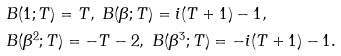Convert formula to latex. <formula><loc_0><loc_0><loc_500><loc_500>& B ( 1 ; T ) = T , \ B ( \beta ; T ) = i ( T + 1 ) - 1 , \\ & B ( \beta ^ { 2 } ; T ) = - T - 2 , \ B ( \beta ^ { 3 } ; T ) = - i ( T + 1 ) - 1 .</formula> 